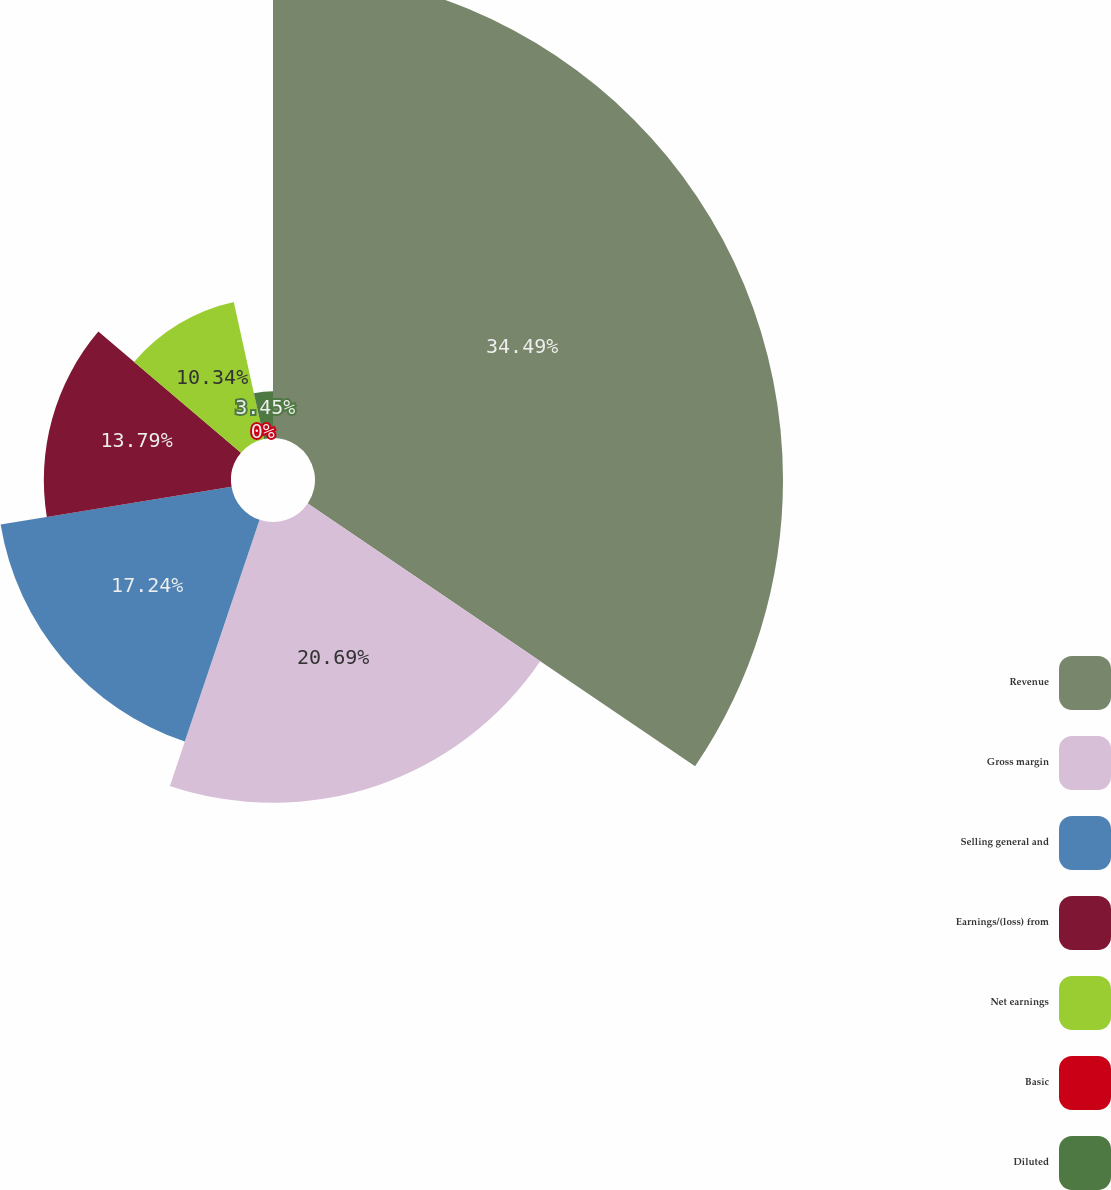Convert chart. <chart><loc_0><loc_0><loc_500><loc_500><pie_chart><fcel>Revenue<fcel>Gross margin<fcel>Selling general and<fcel>Earnings/(loss) from<fcel>Net earnings<fcel>Basic<fcel>Diluted<nl><fcel>34.48%<fcel>20.69%<fcel>17.24%<fcel>13.79%<fcel>10.34%<fcel>0.0%<fcel>3.45%<nl></chart> 